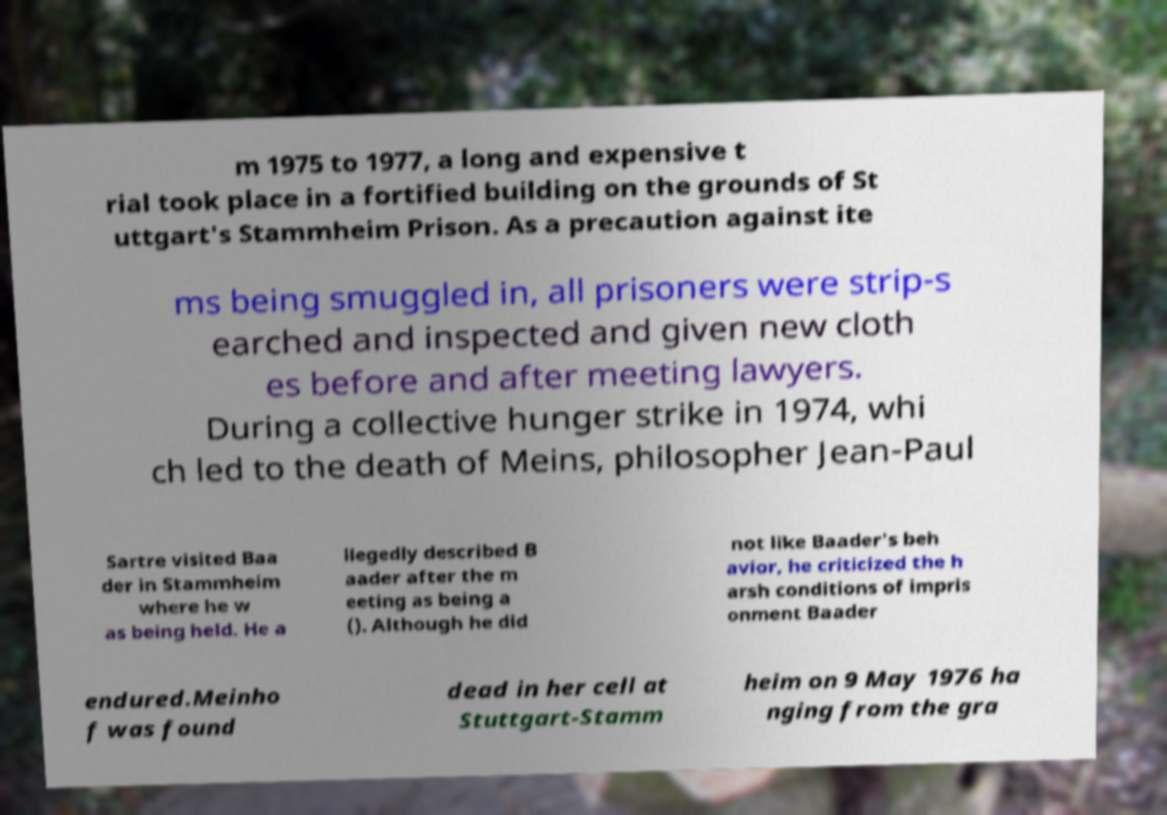Can you read and provide the text displayed in the image?This photo seems to have some interesting text. Can you extract and type it out for me? m 1975 to 1977, a long and expensive t rial took place in a fortified building on the grounds of St uttgart's Stammheim Prison. As a precaution against ite ms being smuggled in, all prisoners were strip-s earched and inspected and given new cloth es before and after meeting lawyers. During a collective hunger strike in 1974, whi ch led to the death of Meins, philosopher Jean-Paul Sartre visited Baa der in Stammheim where he w as being held. He a llegedly described B aader after the m eeting as being a (). Although he did not like Baader's beh avior, he criticized the h arsh conditions of impris onment Baader endured.Meinho f was found dead in her cell at Stuttgart-Stamm heim on 9 May 1976 ha nging from the gra 